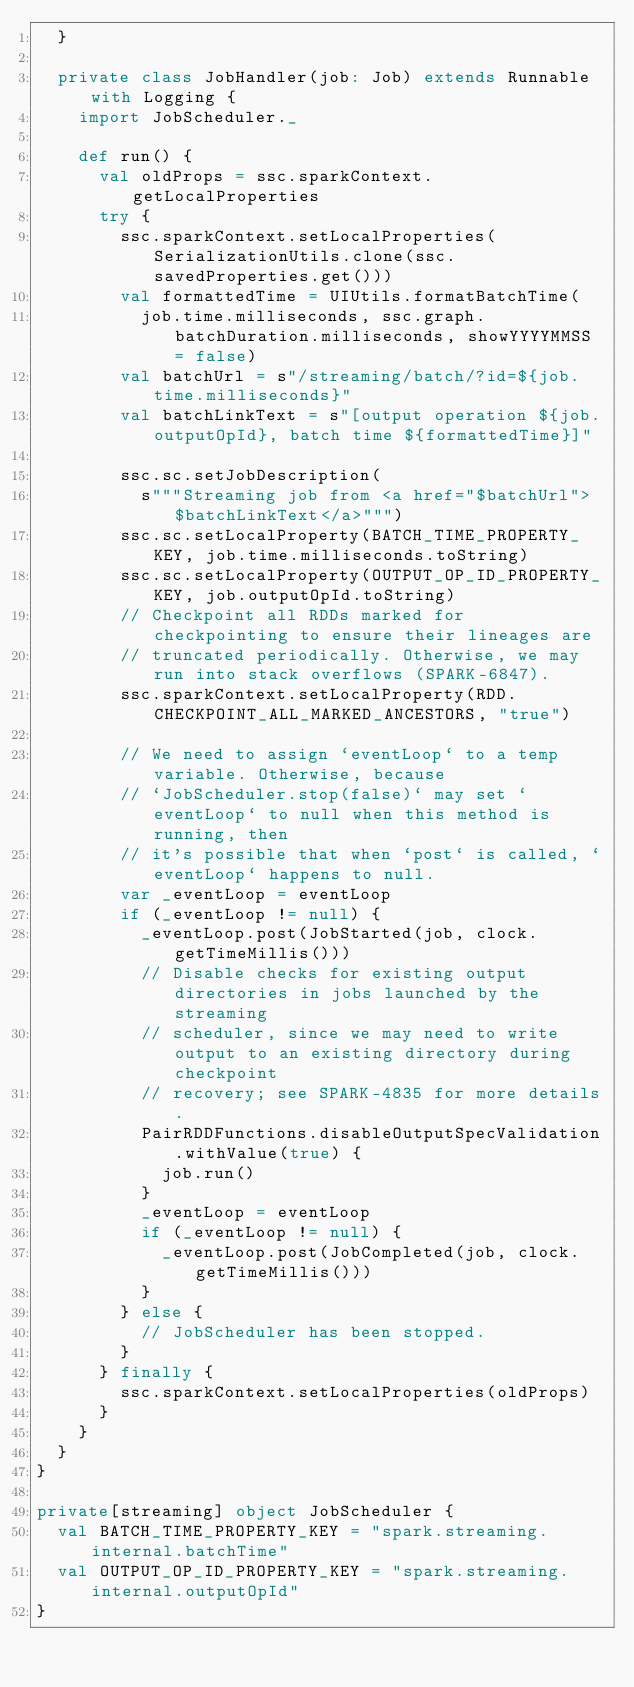Convert code to text. <code><loc_0><loc_0><loc_500><loc_500><_Scala_>  }

  private class JobHandler(job: Job) extends Runnable with Logging {
    import JobScheduler._

    def run() {
      val oldProps = ssc.sparkContext.getLocalProperties
      try {
        ssc.sparkContext.setLocalProperties(SerializationUtils.clone(ssc.savedProperties.get()))
        val formattedTime = UIUtils.formatBatchTime(
          job.time.milliseconds, ssc.graph.batchDuration.milliseconds, showYYYYMMSS = false)
        val batchUrl = s"/streaming/batch/?id=${job.time.milliseconds}"
        val batchLinkText = s"[output operation ${job.outputOpId}, batch time ${formattedTime}]"

        ssc.sc.setJobDescription(
          s"""Streaming job from <a href="$batchUrl">$batchLinkText</a>""")
        ssc.sc.setLocalProperty(BATCH_TIME_PROPERTY_KEY, job.time.milliseconds.toString)
        ssc.sc.setLocalProperty(OUTPUT_OP_ID_PROPERTY_KEY, job.outputOpId.toString)
        // Checkpoint all RDDs marked for checkpointing to ensure their lineages are
        // truncated periodically. Otherwise, we may run into stack overflows (SPARK-6847).
        ssc.sparkContext.setLocalProperty(RDD.CHECKPOINT_ALL_MARKED_ANCESTORS, "true")

        // We need to assign `eventLoop` to a temp variable. Otherwise, because
        // `JobScheduler.stop(false)` may set `eventLoop` to null when this method is running, then
        // it's possible that when `post` is called, `eventLoop` happens to null.
        var _eventLoop = eventLoop
        if (_eventLoop != null) {
          _eventLoop.post(JobStarted(job, clock.getTimeMillis()))
          // Disable checks for existing output directories in jobs launched by the streaming
          // scheduler, since we may need to write output to an existing directory during checkpoint
          // recovery; see SPARK-4835 for more details.
          PairRDDFunctions.disableOutputSpecValidation.withValue(true) {
            job.run()
          }
          _eventLoop = eventLoop
          if (_eventLoop != null) {
            _eventLoop.post(JobCompleted(job, clock.getTimeMillis()))
          }
        } else {
          // JobScheduler has been stopped.
        }
      } finally {
        ssc.sparkContext.setLocalProperties(oldProps)
      }
    }
  }
}

private[streaming] object JobScheduler {
  val BATCH_TIME_PROPERTY_KEY = "spark.streaming.internal.batchTime"
  val OUTPUT_OP_ID_PROPERTY_KEY = "spark.streaming.internal.outputOpId"
}
</code> 